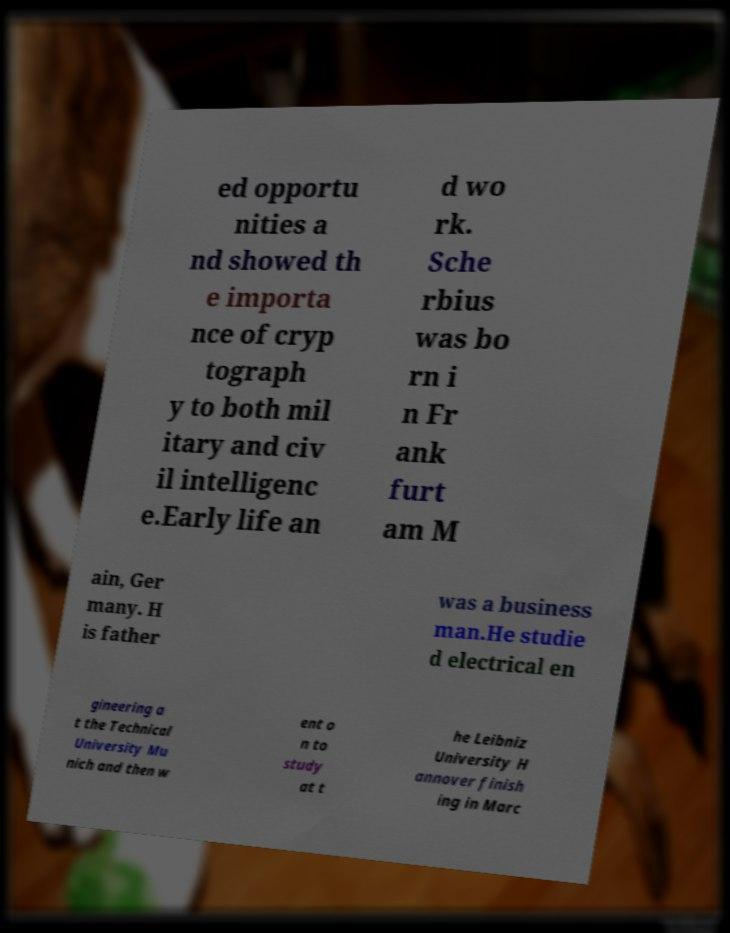What messages or text are displayed in this image? I need them in a readable, typed format. ed opportu nities a nd showed th e importa nce of cryp tograph y to both mil itary and civ il intelligenc e.Early life an d wo rk. Sche rbius was bo rn i n Fr ank furt am M ain, Ger many. H is father was a business man.He studie d electrical en gineering a t the Technical University Mu nich and then w ent o n to study at t he Leibniz University H annover finish ing in Marc 